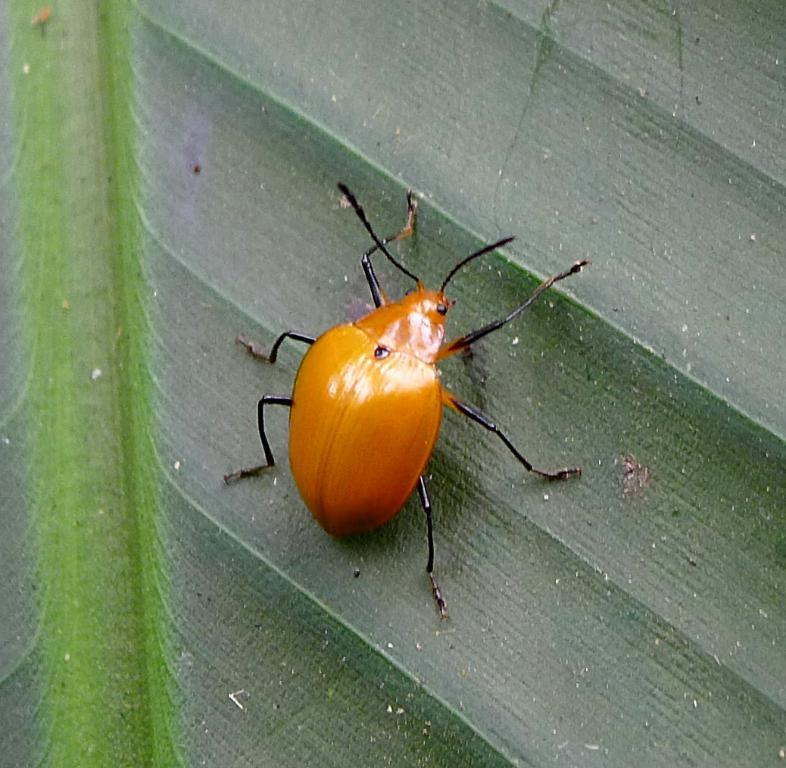What is the main subject in the center of the image? There is a green leaf in the center of the image. What is present on the leaf? There is an insect on the leaf. Can you describe the insect's appearance? The insect has yellow and black colors. How many toes does the insect have in the image? Insects do not have toes, so this detail cannot be determined from the image. 